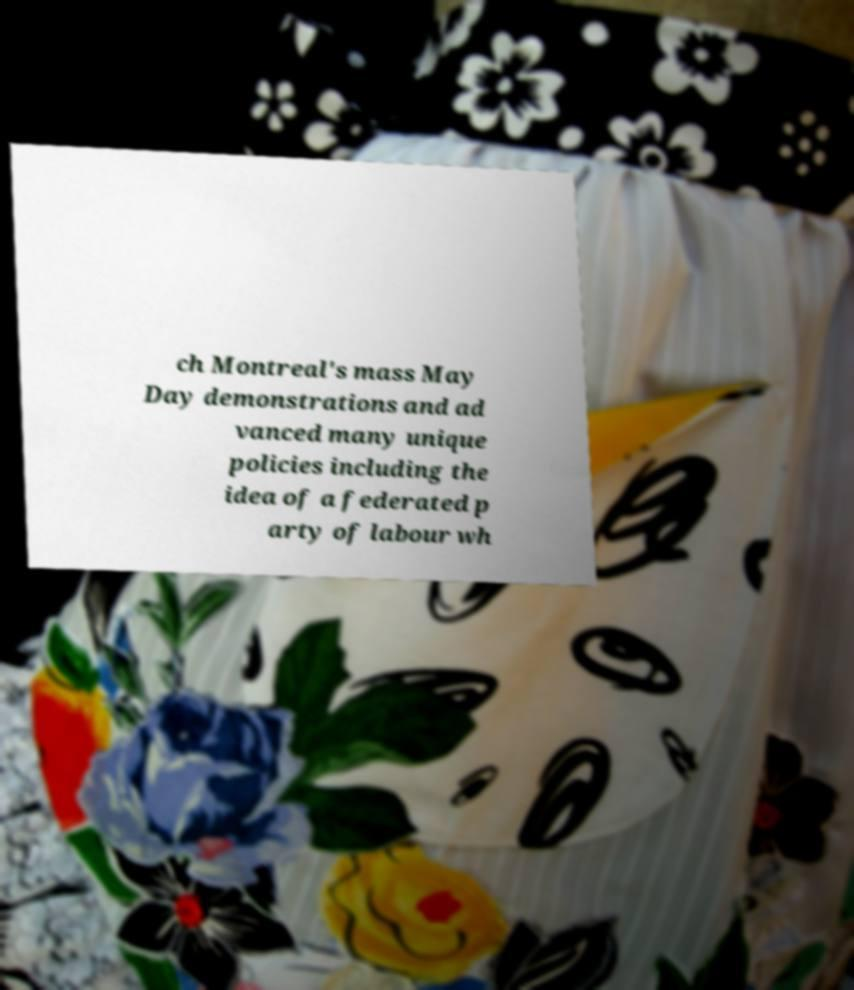What messages or text are displayed in this image? I need them in a readable, typed format. ch Montreal's mass May Day demonstrations and ad vanced many unique policies including the idea of a federated p arty of labour wh 